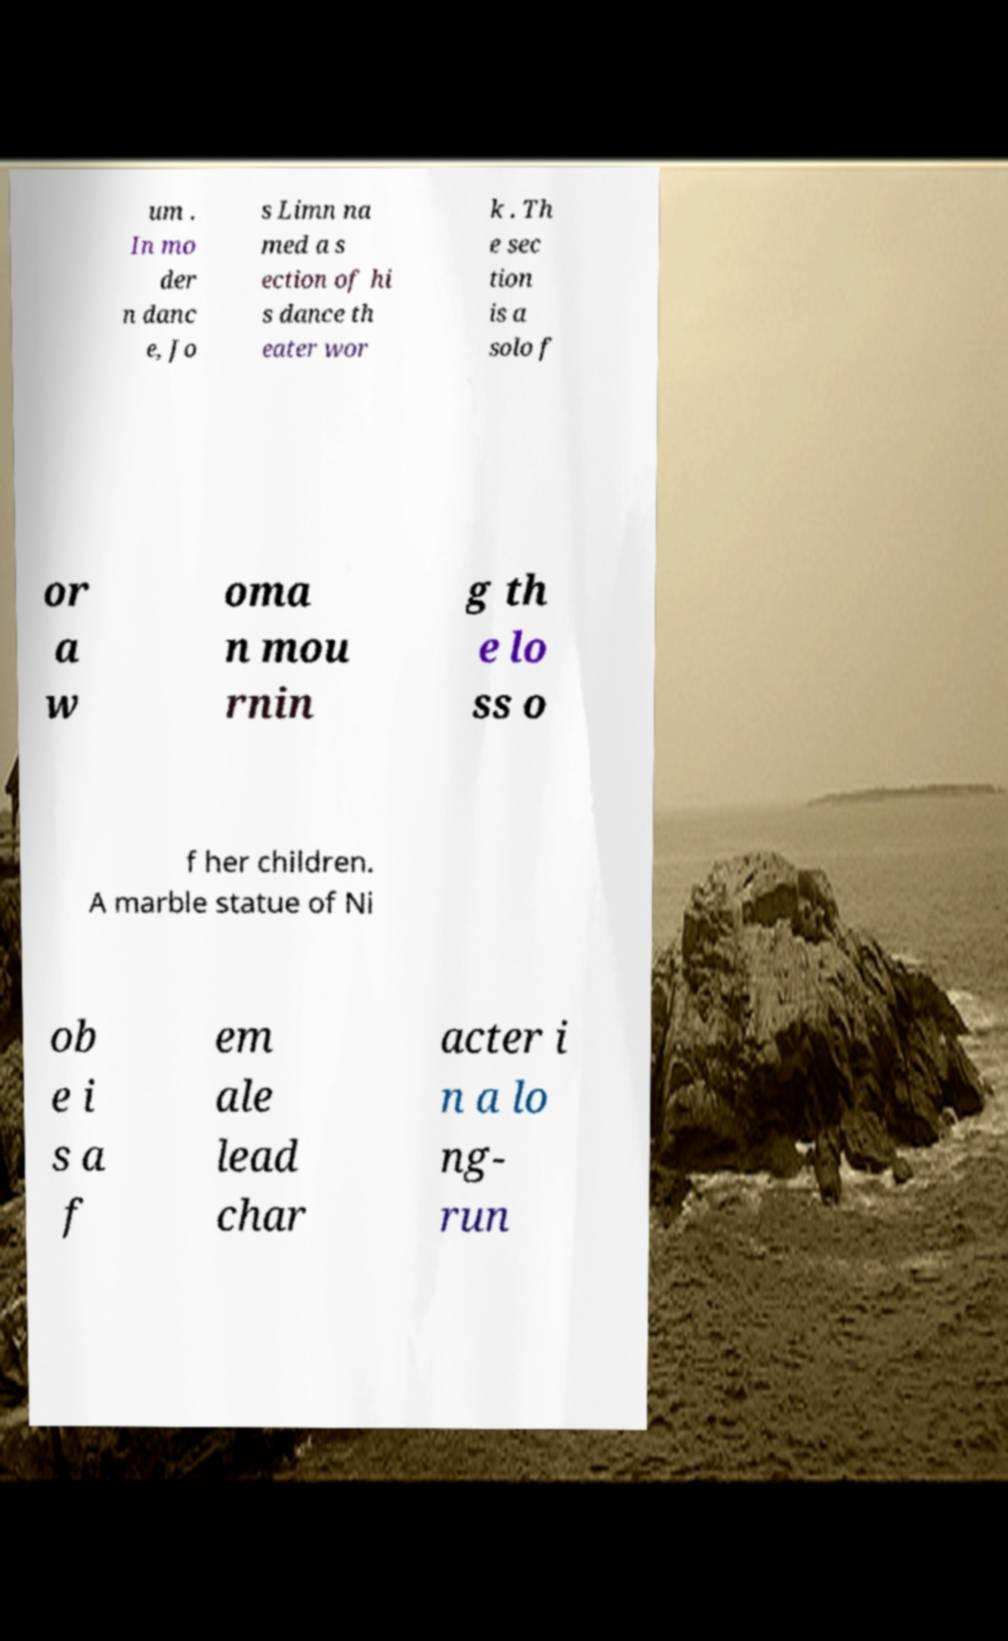What messages or text are displayed in this image? I need them in a readable, typed format. um . In mo der n danc e, Jo s Limn na med a s ection of hi s dance th eater wor k . Th e sec tion is a solo f or a w oma n mou rnin g th e lo ss o f her children. A marble statue of Ni ob e i s a f em ale lead char acter i n a lo ng- run 